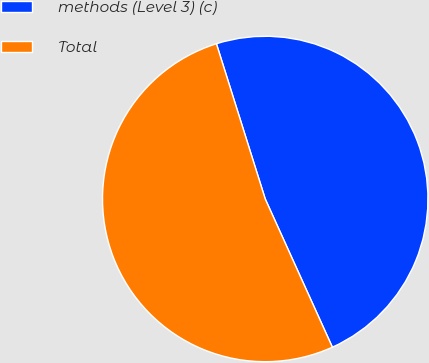Convert chart. <chart><loc_0><loc_0><loc_500><loc_500><pie_chart><fcel>methods (Level 3) (c)<fcel>Total<nl><fcel>48.08%<fcel>51.92%<nl></chart> 